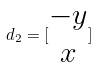Convert formula to latex. <formula><loc_0><loc_0><loc_500><loc_500>d _ { 2 } = [ \begin{matrix} - y \\ x \\ \end{matrix} ]</formula> 